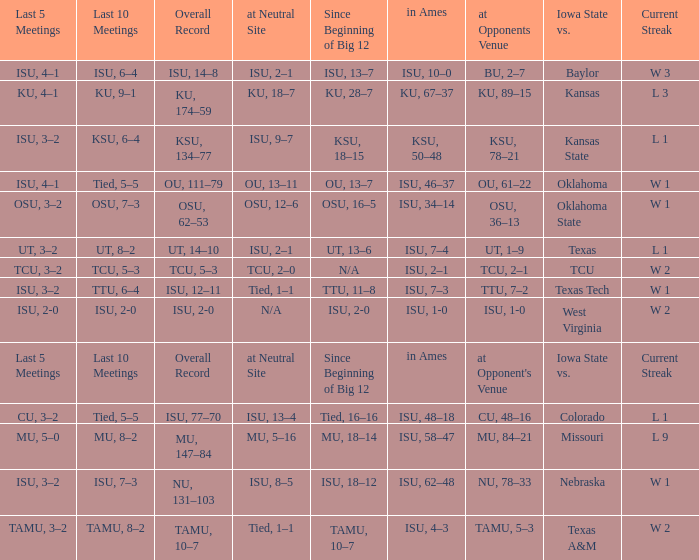When the value of "since beginning of big 12" is synonymous with its' category, what are the in Ames values? In ames. Would you be able to parse every entry in this table? {'header': ['Last 5 Meetings', 'Last 10 Meetings', 'Overall Record', 'at Neutral Site', 'Since Beginning of Big 12', 'in Ames', 'at Opponents Venue', 'Iowa State vs.', 'Current Streak'], 'rows': [['ISU, 4–1', 'ISU, 6–4', 'ISU, 14–8', 'ISU, 2–1', 'ISU, 13–7', 'ISU, 10–0', 'BU, 2–7', 'Baylor', 'W 3'], ['KU, 4–1', 'KU, 9–1', 'KU, 174–59', 'KU, 18–7', 'KU, 28–7', 'KU, 67–37', 'KU, 89–15', 'Kansas', 'L 3'], ['ISU, 3–2', 'KSU, 6–4', 'KSU, 134–77', 'ISU, 9–7', 'KSU, 18–15', 'KSU, 50–48', 'KSU, 78–21', 'Kansas State', 'L 1'], ['ISU, 4–1', 'Tied, 5–5', 'OU, 111–79', 'OU, 13–11', 'OU, 13–7', 'ISU, 46–37', 'OU, 61–22', 'Oklahoma', 'W 1'], ['OSU, 3–2', 'OSU, 7–3', 'OSU, 62–53', 'OSU, 12–6', 'OSU, 16–5', 'ISU, 34–14', 'OSU, 36–13', 'Oklahoma State', 'W 1'], ['UT, 3–2', 'UT, 8–2', 'UT, 14–10', 'ISU, 2–1', 'UT, 13–6', 'ISU, 7–4', 'UT, 1–9', 'Texas', 'L 1'], ['TCU, 3–2', 'TCU, 5–3', 'TCU, 5–3', 'TCU, 2–0', 'N/A', 'ISU, 2–1', 'TCU, 2–1', 'TCU', 'W 2'], ['ISU, 3–2', 'TTU, 6–4', 'ISU, 12–11', 'Tied, 1–1', 'TTU, 11–8', 'ISU, 7–3', 'TTU, 7–2', 'Texas Tech', 'W 1'], ['ISU, 2-0', 'ISU, 2-0', 'ISU, 2-0', 'N/A', 'ISU, 2-0', 'ISU, 1-0', 'ISU, 1-0', 'West Virginia', 'W 2'], ['Last 5 Meetings', 'Last 10 Meetings', 'Overall Record', 'at Neutral Site', 'Since Beginning of Big 12', 'in Ames', "at Opponent's Venue", 'Iowa State vs.', 'Current Streak'], ['CU, 3–2', 'Tied, 5–5', 'ISU, 77–70', 'ISU, 13–4', 'Tied, 16–16', 'ISU, 48–18', 'CU, 48–16', 'Colorado', 'L 1'], ['MU, 5–0', 'MU, 8–2', 'MU, 147–84', 'MU, 5–16', 'MU, 18–14', 'ISU, 58–47', 'MU, 84–21', 'Missouri', 'L 9'], ['ISU, 3–2', 'ISU, 7–3', 'NU, 131–103', 'ISU, 8–5', 'ISU, 18–12', 'ISU, 62–48', 'NU, 78–33', 'Nebraska', 'W 1'], ['TAMU, 3–2', 'TAMU, 8–2', 'TAMU, 10–7', 'Tied, 1–1', 'TAMU, 10–7', 'ISU, 4–3', 'TAMU, 5–3', 'Texas A&M', 'W 2']]} 